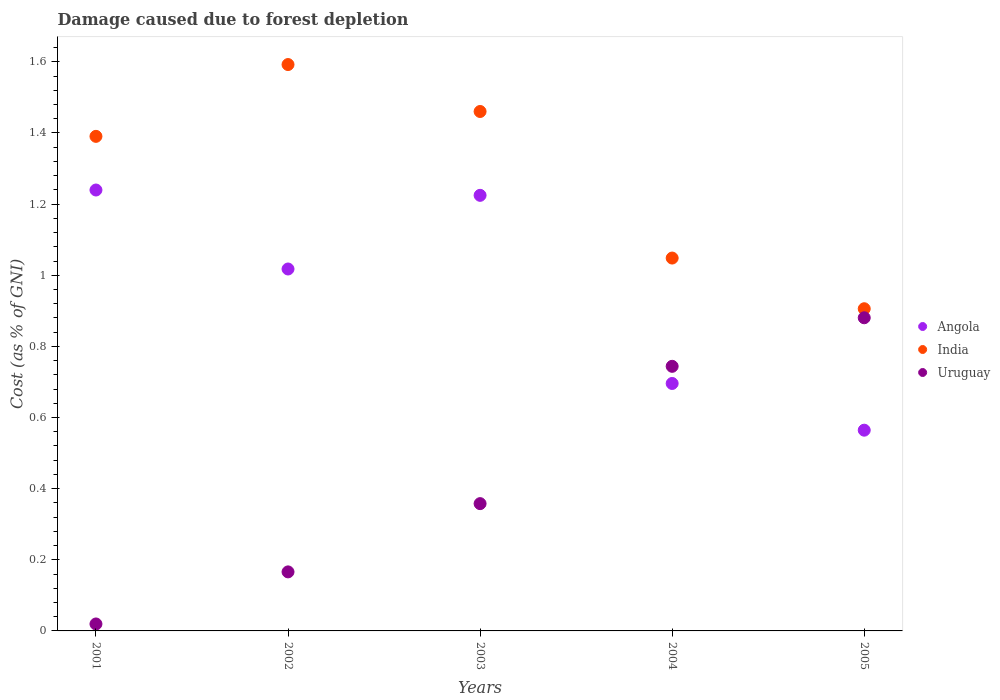What is the cost of damage caused due to forest depletion in Uruguay in 2005?
Ensure brevity in your answer.  0.88. Across all years, what is the maximum cost of damage caused due to forest depletion in Angola?
Offer a very short reply. 1.24. Across all years, what is the minimum cost of damage caused due to forest depletion in Angola?
Keep it short and to the point. 0.56. What is the total cost of damage caused due to forest depletion in Uruguay in the graph?
Give a very brief answer. 2.17. What is the difference between the cost of damage caused due to forest depletion in Uruguay in 2003 and that in 2004?
Ensure brevity in your answer.  -0.39. What is the difference between the cost of damage caused due to forest depletion in India in 2002 and the cost of damage caused due to forest depletion in Angola in 2003?
Make the answer very short. 0.37. What is the average cost of damage caused due to forest depletion in Angola per year?
Offer a very short reply. 0.95. In the year 2003, what is the difference between the cost of damage caused due to forest depletion in Angola and cost of damage caused due to forest depletion in India?
Your answer should be very brief. -0.24. What is the ratio of the cost of damage caused due to forest depletion in India in 2003 to that in 2005?
Give a very brief answer. 1.61. Is the difference between the cost of damage caused due to forest depletion in Angola in 2002 and 2004 greater than the difference between the cost of damage caused due to forest depletion in India in 2002 and 2004?
Ensure brevity in your answer.  No. What is the difference between the highest and the second highest cost of damage caused due to forest depletion in Angola?
Provide a succinct answer. 0.01. What is the difference between the highest and the lowest cost of damage caused due to forest depletion in Angola?
Offer a terse response. 0.68. Is it the case that in every year, the sum of the cost of damage caused due to forest depletion in Uruguay and cost of damage caused due to forest depletion in India  is greater than the cost of damage caused due to forest depletion in Angola?
Keep it short and to the point. Yes. Does the cost of damage caused due to forest depletion in India monotonically increase over the years?
Your answer should be compact. No. How many years are there in the graph?
Keep it short and to the point. 5. Are the values on the major ticks of Y-axis written in scientific E-notation?
Ensure brevity in your answer.  No. How many legend labels are there?
Keep it short and to the point. 3. What is the title of the graph?
Offer a very short reply. Damage caused due to forest depletion. Does "Pacific island small states" appear as one of the legend labels in the graph?
Your answer should be compact. No. What is the label or title of the X-axis?
Offer a terse response. Years. What is the label or title of the Y-axis?
Your answer should be very brief. Cost (as % of GNI). What is the Cost (as % of GNI) of Angola in 2001?
Offer a very short reply. 1.24. What is the Cost (as % of GNI) of India in 2001?
Ensure brevity in your answer.  1.39. What is the Cost (as % of GNI) of Uruguay in 2001?
Your response must be concise. 0.02. What is the Cost (as % of GNI) in Angola in 2002?
Offer a terse response. 1.02. What is the Cost (as % of GNI) of India in 2002?
Your answer should be very brief. 1.59. What is the Cost (as % of GNI) in Uruguay in 2002?
Make the answer very short. 0.17. What is the Cost (as % of GNI) of Angola in 2003?
Keep it short and to the point. 1.22. What is the Cost (as % of GNI) in India in 2003?
Offer a terse response. 1.46. What is the Cost (as % of GNI) in Uruguay in 2003?
Keep it short and to the point. 0.36. What is the Cost (as % of GNI) of Angola in 2004?
Make the answer very short. 0.7. What is the Cost (as % of GNI) in India in 2004?
Offer a terse response. 1.05. What is the Cost (as % of GNI) in Uruguay in 2004?
Provide a short and direct response. 0.74. What is the Cost (as % of GNI) in Angola in 2005?
Provide a succinct answer. 0.56. What is the Cost (as % of GNI) in India in 2005?
Provide a succinct answer. 0.91. What is the Cost (as % of GNI) of Uruguay in 2005?
Your response must be concise. 0.88. Across all years, what is the maximum Cost (as % of GNI) of Angola?
Provide a succinct answer. 1.24. Across all years, what is the maximum Cost (as % of GNI) in India?
Offer a terse response. 1.59. Across all years, what is the maximum Cost (as % of GNI) in Uruguay?
Provide a succinct answer. 0.88. Across all years, what is the minimum Cost (as % of GNI) in Angola?
Give a very brief answer. 0.56. Across all years, what is the minimum Cost (as % of GNI) of India?
Offer a terse response. 0.91. Across all years, what is the minimum Cost (as % of GNI) of Uruguay?
Provide a succinct answer. 0.02. What is the total Cost (as % of GNI) in Angola in the graph?
Your answer should be very brief. 4.74. What is the total Cost (as % of GNI) of India in the graph?
Your answer should be very brief. 6.4. What is the total Cost (as % of GNI) of Uruguay in the graph?
Your answer should be very brief. 2.17. What is the difference between the Cost (as % of GNI) in Angola in 2001 and that in 2002?
Provide a short and direct response. 0.22. What is the difference between the Cost (as % of GNI) of India in 2001 and that in 2002?
Give a very brief answer. -0.2. What is the difference between the Cost (as % of GNI) in Uruguay in 2001 and that in 2002?
Give a very brief answer. -0.15. What is the difference between the Cost (as % of GNI) of Angola in 2001 and that in 2003?
Make the answer very short. 0.01. What is the difference between the Cost (as % of GNI) of India in 2001 and that in 2003?
Provide a succinct answer. -0.07. What is the difference between the Cost (as % of GNI) of Uruguay in 2001 and that in 2003?
Your answer should be very brief. -0.34. What is the difference between the Cost (as % of GNI) of Angola in 2001 and that in 2004?
Ensure brevity in your answer.  0.54. What is the difference between the Cost (as % of GNI) in India in 2001 and that in 2004?
Your answer should be very brief. 0.34. What is the difference between the Cost (as % of GNI) of Uruguay in 2001 and that in 2004?
Offer a terse response. -0.72. What is the difference between the Cost (as % of GNI) of Angola in 2001 and that in 2005?
Your response must be concise. 0.68. What is the difference between the Cost (as % of GNI) in India in 2001 and that in 2005?
Give a very brief answer. 0.48. What is the difference between the Cost (as % of GNI) in Uruguay in 2001 and that in 2005?
Keep it short and to the point. -0.86. What is the difference between the Cost (as % of GNI) in Angola in 2002 and that in 2003?
Keep it short and to the point. -0.21. What is the difference between the Cost (as % of GNI) in India in 2002 and that in 2003?
Give a very brief answer. 0.13. What is the difference between the Cost (as % of GNI) in Uruguay in 2002 and that in 2003?
Ensure brevity in your answer.  -0.19. What is the difference between the Cost (as % of GNI) of Angola in 2002 and that in 2004?
Your answer should be compact. 0.32. What is the difference between the Cost (as % of GNI) of India in 2002 and that in 2004?
Offer a very short reply. 0.54. What is the difference between the Cost (as % of GNI) in Uruguay in 2002 and that in 2004?
Your response must be concise. -0.58. What is the difference between the Cost (as % of GNI) of Angola in 2002 and that in 2005?
Provide a short and direct response. 0.45. What is the difference between the Cost (as % of GNI) in India in 2002 and that in 2005?
Ensure brevity in your answer.  0.69. What is the difference between the Cost (as % of GNI) in Uruguay in 2002 and that in 2005?
Provide a short and direct response. -0.71. What is the difference between the Cost (as % of GNI) of Angola in 2003 and that in 2004?
Offer a very short reply. 0.53. What is the difference between the Cost (as % of GNI) in India in 2003 and that in 2004?
Make the answer very short. 0.41. What is the difference between the Cost (as % of GNI) in Uruguay in 2003 and that in 2004?
Your response must be concise. -0.39. What is the difference between the Cost (as % of GNI) of Angola in 2003 and that in 2005?
Your answer should be compact. 0.66. What is the difference between the Cost (as % of GNI) in India in 2003 and that in 2005?
Your answer should be compact. 0.55. What is the difference between the Cost (as % of GNI) in Uruguay in 2003 and that in 2005?
Your answer should be very brief. -0.52. What is the difference between the Cost (as % of GNI) of Angola in 2004 and that in 2005?
Offer a very short reply. 0.13. What is the difference between the Cost (as % of GNI) of India in 2004 and that in 2005?
Ensure brevity in your answer.  0.14. What is the difference between the Cost (as % of GNI) of Uruguay in 2004 and that in 2005?
Ensure brevity in your answer.  -0.14. What is the difference between the Cost (as % of GNI) in Angola in 2001 and the Cost (as % of GNI) in India in 2002?
Make the answer very short. -0.35. What is the difference between the Cost (as % of GNI) in Angola in 2001 and the Cost (as % of GNI) in Uruguay in 2002?
Your answer should be compact. 1.07. What is the difference between the Cost (as % of GNI) of India in 2001 and the Cost (as % of GNI) of Uruguay in 2002?
Your answer should be compact. 1.22. What is the difference between the Cost (as % of GNI) in Angola in 2001 and the Cost (as % of GNI) in India in 2003?
Offer a terse response. -0.22. What is the difference between the Cost (as % of GNI) of Angola in 2001 and the Cost (as % of GNI) of Uruguay in 2003?
Offer a very short reply. 0.88. What is the difference between the Cost (as % of GNI) of India in 2001 and the Cost (as % of GNI) of Uruguay in 2003?
Make the answer very short. 1.03. What is the difference between the Cost (as % of GNI) in Angola in 2001 and the Cost (as % of GNI) in India in 2004?
Your answer should be compact. 0.19. What is the difference between the Cost (as % of GNI) of Angola in 2001 and the Cost (as % of GNI) of Uruguay in 2004?
Your answer should be very brief. 0.5. What is the difference between the Cost (as % of GNI) of India in 2001 and the Cost (as % of GNI) of Uruguay in 2004?
Offer a very short reply. 0.65. What is the difference between the Cost (as % of GNI) of Angola in 2001 and the Cost (as % of GNI) of India in 2005?
Make the answer very short. 0.33. What is the difference between the Cost (as % of GNI) in Angola in 2001 and the Cost (as % of GNI) in Uruguay in 2005?
Your response must be concise. 0.36. What is the difference between the Cost (as % of GNI) of India in 2001 and the Cost (as % of GNI) of Uruguay in 2005?
Give a very brief answer. 0.51. What is the difference between the Cost (as % of GNI) in Angola in 2002 and the Cost (as % of GNI) in India in 2003?
Give a very brief answer. -0.44. What is the difference between the Cost (as % of GNI) of Angola in 2002 and the Cost (as % of GNI) of Uruguay in 2003?
Provide a short and direct response. 0.66. What is the difference between the Cost (as % of GNI) of India in 2002 and the Cost (as % of GNI) of Uruguay in 2003?
Keep it short and to the point. 1.23. What is the difference between the Cost (as % of GNI) of Angola in 2002 and the Cost (as % of GNI) of India in 2004?
Give a very brief answer. -0.03. What is the difference between the Cost (as % of GNI) of Angola in 2002 and the Cost (as % of GNI) of Uruguay in 2004?
Make the answer very short. 0.27. What is the difference between the Cost (as % of GNI) of India in 2002 and the Cost (as % of GNI) of Uruguay in 2004?
Ensure brevity in your answer.  0.85. What is the difference between the Cost (as % of GNI) of Angola in 2002 and the Cost (as % of GNI) of India in 2005?
Offer a terse response. 0.11. What is the difference between the Cost (as % of GNI) in Angola in 2002 and the Cost (as % of GNI) in Uruguay in 2005?
Offer a very short reply. 0.14. What is the difference between the Cost (as % of GNI) in India in 2002 and the Cost (as % of GNI) in Uruguay in 2005?
Ensure brevity in your answer.  0.71. What is the difference between the Cost (as % of GNI) of Angola in 2003 and the Cost (as % of GNI) of India in 2004?
Your response must be concise. 0.18. What is the difference between the Cost (as % of GNI) of Angola in 2003 and the Cost (as % of GNI) of Uruguay in 2004?
Your answer should be very brief. 0.48. What is the difference between the Cost (as % of GNI) in India in 2003 and the Cost (as % of GNI) in Uruguay in 2004?
Your answer should be very brief. 0.72. What is the difference between the Cost (as % of GNI) in Angola in 2003 and the Cost (as % of GNI) in India in 2005?
Provide a succinct answer. 0.32. What is the difference between the Cost (as % of GNI) in Angola in 2003 and the Cost (as % of GNI) in Uruguay in 2005?
Provide a succinct answer. 0.34. What is the difference between the Cost (as % of GNI) in India in 2003 and the Cost (as % of GNI) in Uruguay in 2005?
Your answer should be very brief. 0.58. What is the difference between the Cost (as % of GNI) in Angola in 2004 and the Cost (as % of GNI) in India in 2005?
Offer a terse response. -0.21. What is the difference between the Cost (as % of GNI) in Angola in 2004 and the Cost (as % of GNI) in Uruguay in 2005?
Offer a very short reply. -0.18. What is the difference between the Cost (as % of GNI) of India in 2004 and the Cost (as % of GNI) of Uruguay in 2005?
Make the answer very short. 0.17. What is the average Cost (as % of GNI) of Angola per year?
Offer a terse response. 0.95. What is the average Cost (as % of GNI) in India per year?
Make the answer very short. 1.28. What is the average Cost (as % of GNI) of Uruguay per year?
Keep it short and to the point. 0.43. In the year 2001, what is the difference between the Cost (as % of GNI) of Angola and Cost (as % of GNI) of India?
Provide a short and direct response. -0.15. In the year 2001, what is the difference between the Cost (as % of GNI) in Angola and Cost (as % of GNI) in Uruguay?
Make the answer very short. 1.22. In the year 2001, what is the difference between the Cost (as % of GNI) in India and Cost (as % of GNI) in Uruguay?
Your answer should be compact. 1.37. In the year 2002, what is the difference between the Cost (as % of GNI) of Angola and Cost (as % of GNI) of India?
Provide a succinct answer. -0.57. In the year 2002, what is the difference between the Cost (as % of GNI) in Angola and Cost (as % of GNI) in Uruguay?
Make the answer very short. 0.85. In the year 2002, what is the difference between the Cost (as % of GNI) in India and Cost (as % of GNI) in Uruguay?
Your answer should be compact. 1.43. In the year 2003, what is the difference between the Cost (as % of GNI) in Angola and Cost (as % of GNI) in India?
Keep it short and to the point. -0.24. In the year 2003, what is the difference between the Cost (as % of GNI) of Angola and Cost (as % of GNI) of Uruguay?
Provide a short and direct response. 0.87. In the year 2003, what is the difference between the Cost (as % of GNI) in India and Cost (as % of GNI) in Uruguay?
Offer a terse response. 1.1. In the year 2004, what is the difference between the Cost (as % of GNI) in Angola and Cost (as % of GNI) in India?
Your answer should be compact. -0.35. In the year 2004, what is the difference between the Cost (as % of GNI) of Angola and Cost (as % of GNI) of Uruguay?
Make the answer very short. -0.05. In the year 2004, what is the difference between the Cost (as % of GNI) in India and Cost (as % of GNI) in Uruguay?
Your answer should be very brief. 0.3. In the year 2005, what is the difference between the Cost (as % of GNI) of Angola and Cost (as % of GNI) of India?
Your answer should be compact. -0.34. In the year 2005, what is the difference between the Cost (as % of GNI) of Angola and Cost (as % of GNI) of Uruguay?
Your response must be concise. -0.32. In the year 2005, what is the difference between the Cost (as % of GNI) in India and Cost (as % of GNI) in Uruguay?
Your answer should be very brief. 0.03. What is the ratio of the Cost (as % of GNI) of Angola in 2001 to that in 2002?
Offer a terse response. 1.22. What is the ratio of the Cost (as % of GNI) in India in 2001 to that in 2002?
Your answer should be compact. 0.87. What is the ratio of the Cost (as % of GNI) of Uruguay in 2001 to that in 2002?
Offer a terse response. 0.12. What is the ratio of the Cost (as % of GNI) of Angola in 2001 to that in 2003?
Keep it short and to the point. 1.01. What is the ratio of the Cost (as % of GNI) of India in 2001 to that in 2003?
Offer a terse response. 0.95. What is the ratio of the Cost (as % of GNI) in Uruguay in 2001 to that in 2003?
Offer a very short reply. 0.05. What is the ratio of the Cost (as % of GNI) of Angola in 2001 to that in 2004?
Keep it short and to the point. 1.78. What is the ratio of the Cost (as % of GNI) in India in 2001 to that in 2004?
Your answer should be compact. 1.33. What is the ratio of the Cost (as % of GNI) of Uruguay in 2001 to that in 2004?
Offer a terse response. 0.03. What is the ratio of the Cost (as % of GNI) in Angola in 2001 to that in 2005?
Give a very brief answer. 2.2. What is the ratio of the Cost (as % of GNI) in India in 2001 to that in 2005?
Offer a very short reply. 1.54. What is the ratio of the Cost (as % of GNI) in Uruguay in 2001 to that in 2005?
Provide a short and direct response. 0.02. What is the ratio of the Cost (as % of GNI) of Angola in 2002 to that in 2003?
Provide a short and direct response. 0.83. What is the ratio of the Cost (as % of GNI) of India in 2002 to that in 2003?
Offer a terse response. 1.09. What is the ratio of the Cost (as % of GNI) of Uruguay in 2002 to that in 2003?
Offer a terse response. 0.46. What is the ratio of the Cost (as % of GNI) of Angola in 2002 to that in 2004?
Provide a short and direct response. 1.46. What is the ratio of the Cost (as % of GNI) in India in 2002 to that in 2004?
Provide a succinct answer. 1.52. What is the ratio of the Cost (as % of GNI) of Uruguay in 2002 to that in 2004?
Provide a short and direct response. 0.22. What is the ratio of the Cost (as % of GNI) in Angola in 2002 to that in 2005?
Your response must be concise. 1.8. What is the ratio of the Cost (as % of GNI) in India in 2002 to that in 2005?
Make the answer very short. 1.76. What is the ratio of the Cost (as % of GNI) of Uruguay in 2002 to that in 2005?
Your answer should be very brief. 0.19. What is the ratio of the Cost (as % of GNI) of Angola in 2003 to that in 2004?
Keep it short and to the point. 1.76. What is the ratio of the Cost (as % of GNI) in India in 2003 to that in 2004?
Provide a succinct answer. 1.39. What is the ratio of the Cost (as % of GNI) of Uruguay in 2003 to that in 2004?
Your answer should be compact. 0.48. What is the ratio of the Cost (as % of GNI) of Angola in 2003 to that in 2005?
Make the answer very short. 2.17. What is the ratio of the Cost (as % of GNI) of India in 2003 to that in 2005?
Provide a short and direct response. 1.61. What is the ratio of the Cost (as % of GNI) in Uruguay in 2003 to that in 2005?
Offer a very short reply. 0.41. What is the ratio of the Cost (as % of GNI) in Angola in 2004 to that in 2005?
Your response must be concise. 1.23. What is the ratio of the Cost (as % of GNI) in India in 2004 to that in 2005?
Offer a terse response. 1.16. What is the ratio of the Cost (as % of GNI) of Uruguay in 2004 to that in 2005?
Offer a very short reply. 0.84. What is the difference between the highest and the second highest Cost (as % of GNI) in Angola?
Offer a terse response. 0.01. What is the difference between the highest and the second highest Cost (as % of GNI) in India?
Give a very brief answer. 0.13. What is the difference between the highest and the second highest Cost (as % of GNI) in Uruguay?
Keep it short and to the point. 0.14. What is the difference between the highest and the lowest Cost (as % of GNI) of Angola?
Your answer should be compact. 0.68. What is the difference between the highest and the lowest Cost (as % of GNI) of India?
Your answer should be compact. 0.69. What is the difference between the highest and the lowest Cost (as % of GNI) of Uruguay?
Offer a terse response. 0.86. 